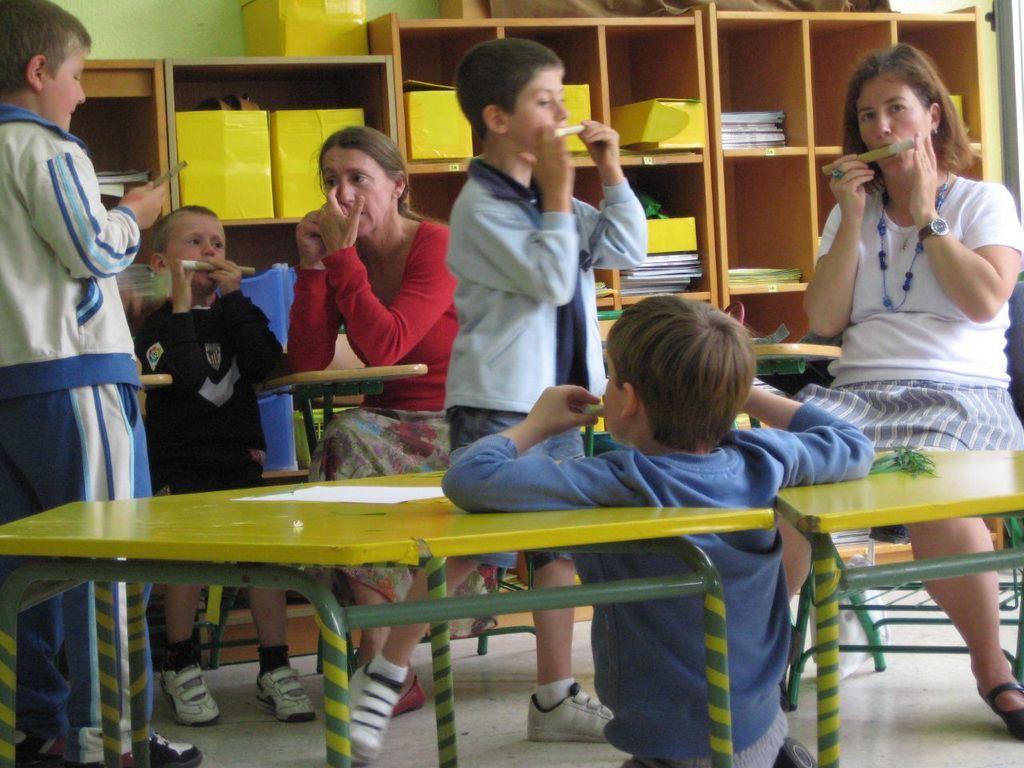In one or two sentences, can you explain what this image depicts? In this picture there are women sitting in the bench in front of a table. There are children playing a flute in this room. In the background, there is cup board and some books which were placed in them. 